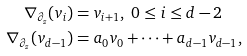Convert formula to latex. <formula><loc_0><loc_0><loc_500><loc_500>\nabla _ { \partial _ { z } } ( v _ { i } ) & = v _ { i + 1 } , \ 0 \leq i \leq d - 2 \\ \nabla _ { \partial _ { z } } ( v _ { d - 1 } ) & = a _ { 0 } v _ { 0 } + \cdots + a _ { d - 1 } v _ { d - 1 } ,</formula> 